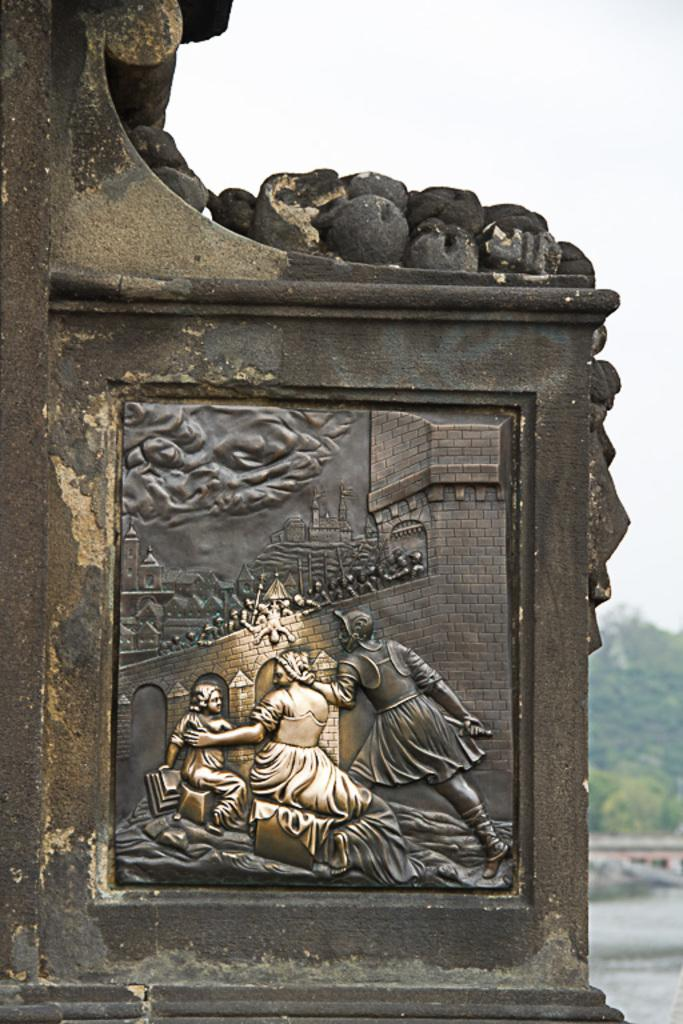What is on the wall in the image? There is a sculpture on the wall in the image. What is visible behind the sculpture? Water is visible behind the sculpture. What type of structure can be seen in the image? There is a building in the image. What type of vegetation is present in the image? There are trees in the image. What is visible at the top of the image? The sky is visible at the top of the image. What type of drain is visible in the image? There is no drain present in the image. What type of quilt is draped over the sculpture in the image? There is no quilt present in the image; it features a sculpture on the wall with water visible behind it. 